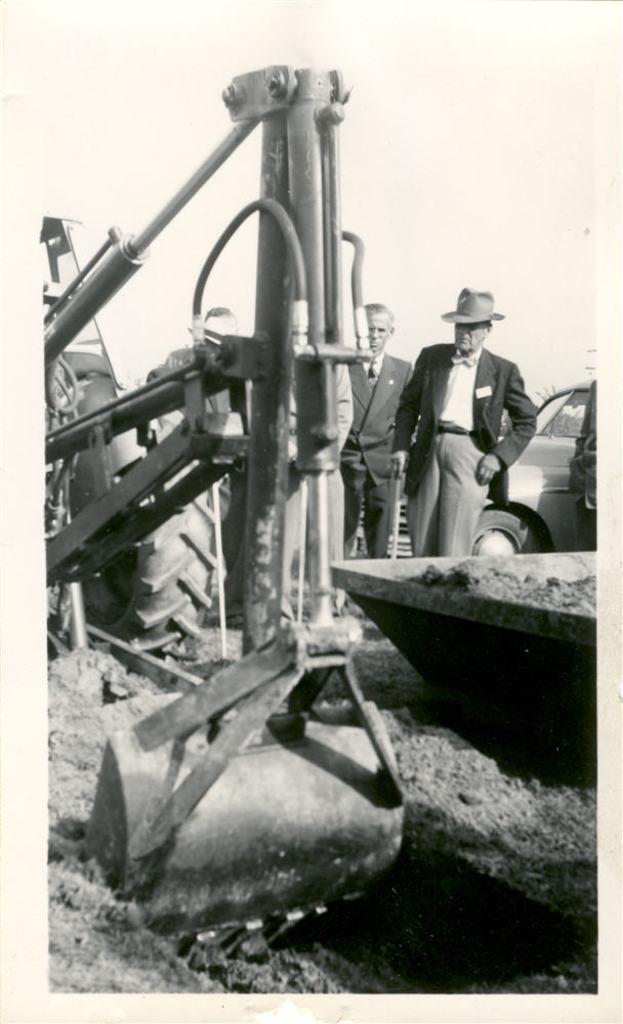Can you describe this image briefly? In this picture there is a tractor on the left side of the image and there are people and a car in the background area of the image. 